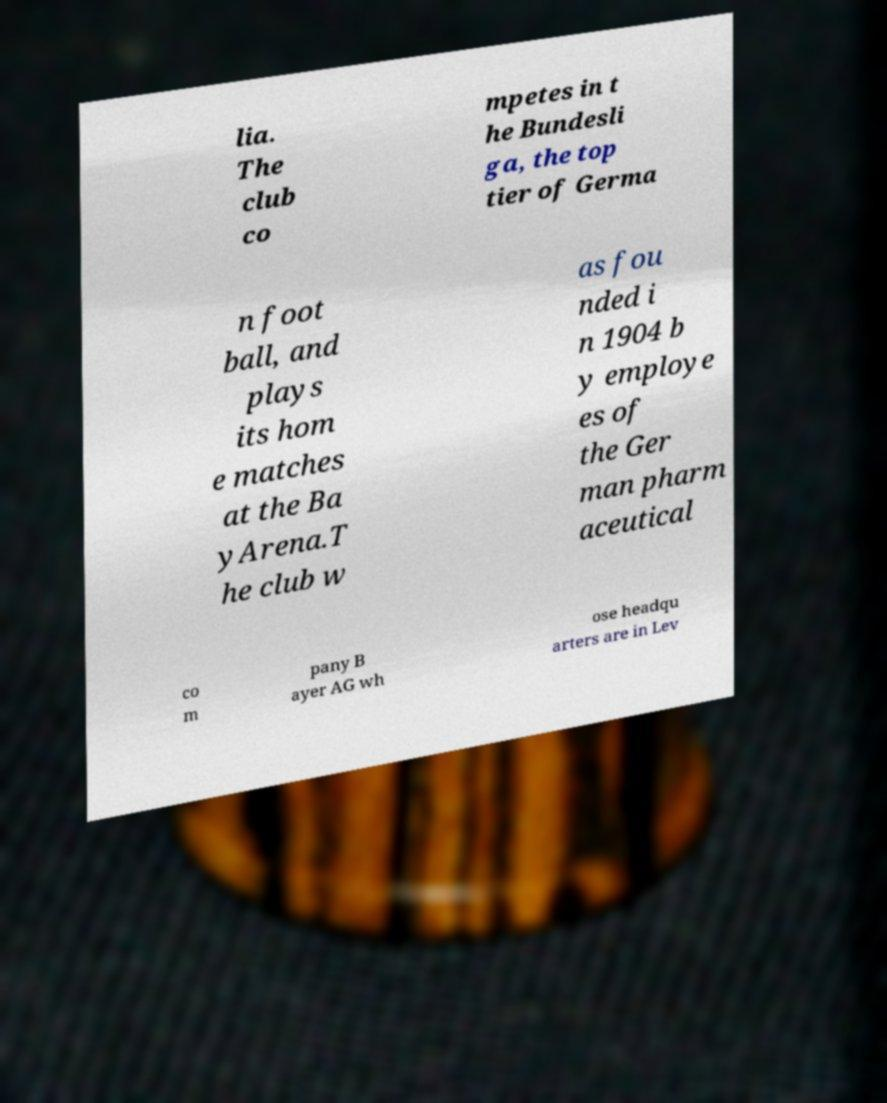Could you extract and type out the text from this image? lia. The club co mpetes in t he Bundesli ga, the top tier of Germa n foot ball, and plays its hom e matches at the Ba yArena.T he club w as fou nded i n 1904 b y employe es of the Ger man pharm aceutical co m pany B ayer AG wh ose headqu arters are in Lev 